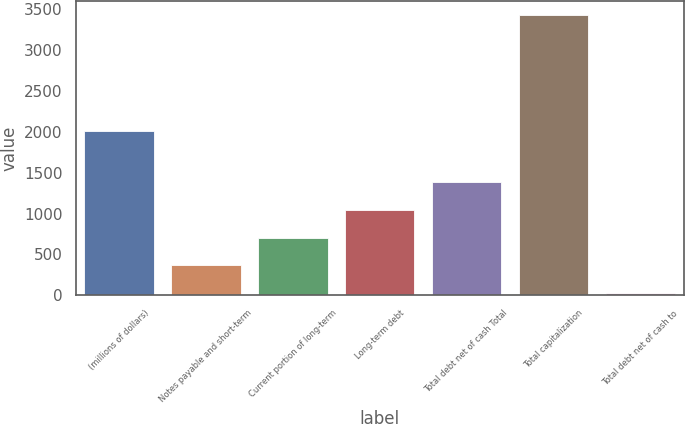Convert chart. <chart><loc_0><loc_0><loc_500><loc_500><bar_chart><fcel>(millions of dollars)<fcel>Notes payable and short-term<fcel>Current portion of long-term<fcel>Long-term debt<fcel>Total debt net of cash Total<fcel>Total capitalization<fcel>Total debt net of cash to<nl><fcel>2011<fcel>367.72<fcel>707.14<fcel>1046.56<fcel>1385.98<fcel>3422.5<fcel>28.3<nl></chart> 